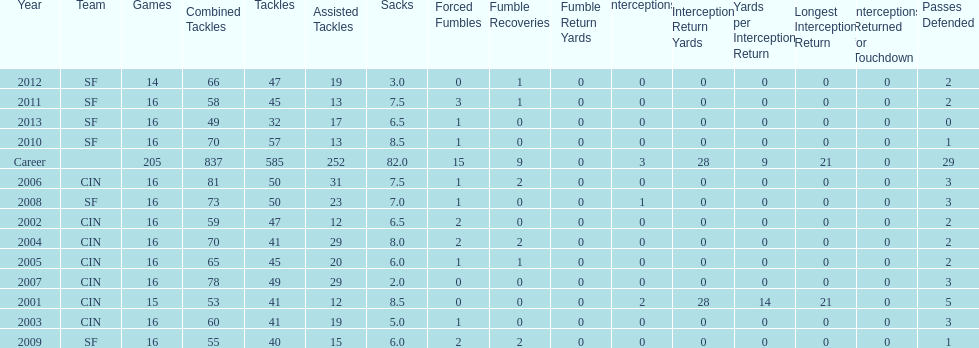How many consecutive seasons has he played sixteen games? 10. 